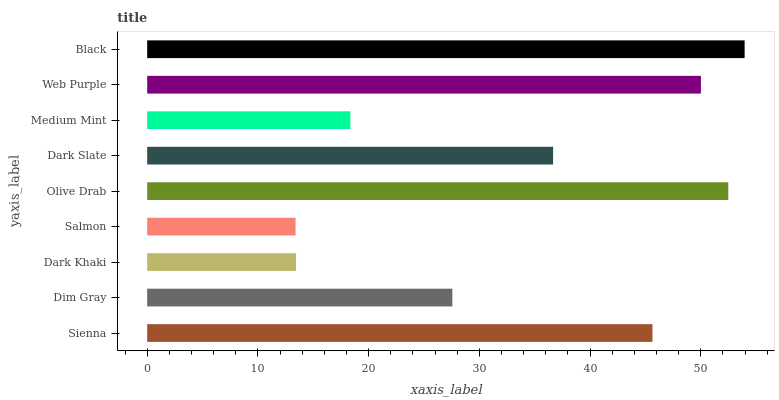Is Salmon the minimum?
Answer yes or no. Yes. Is Black the maximum?
Answer yes or no. Yes. Is Dim Gray the minimum?
Answer yes or no. No. Is Dim Gray the maximum?
Answer yes or no. No. Is Sienna greater than Dim Gray?
Answer yes or no. Yes. Is Dim Gray less than Sienna?
Answer yes or no. Yes. Is Dim Gray greater than Sienna?
Answer yes or no. No. Is Sienna less than Dim Gray?
Answer yes or no. No. Is Dark Slate the high median?
Answer yes or no. Yes. Is Dark Slate the low median?
Answer yes or no. Yes. Is Black the high median?
Answer yes or no. No. Is Web Purple the low median?
Answer yes or no. No. 